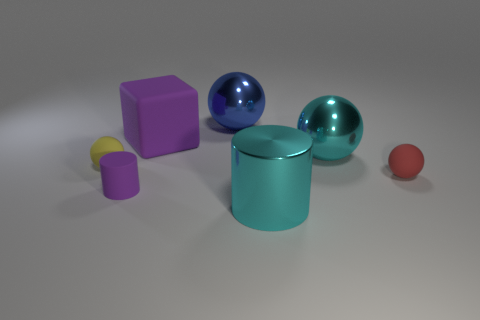Subtract all red balls. How many balls are left? 3 Add 2 red things. How many objects exist? 9 Subtract all purple cylinders. How many cylinders are left? 1 Subtract 0 red cylinders. How many objects are left? 7 Subtract all cylinders. How many objects are left? 5 Subtract 1 cylinders. How many cylinders are left? 1 Subtract all green cylinders. Subtract all yellow cubes. How many cylinders are left? 2 Subtract all green cylinders. How many yellow blocks are left? 0 Subtract all brown metallic balls. Subtract all small yellow objects. How many objects are left? 6 Add 4 large cylinders. How many large cylinders are left? 5 